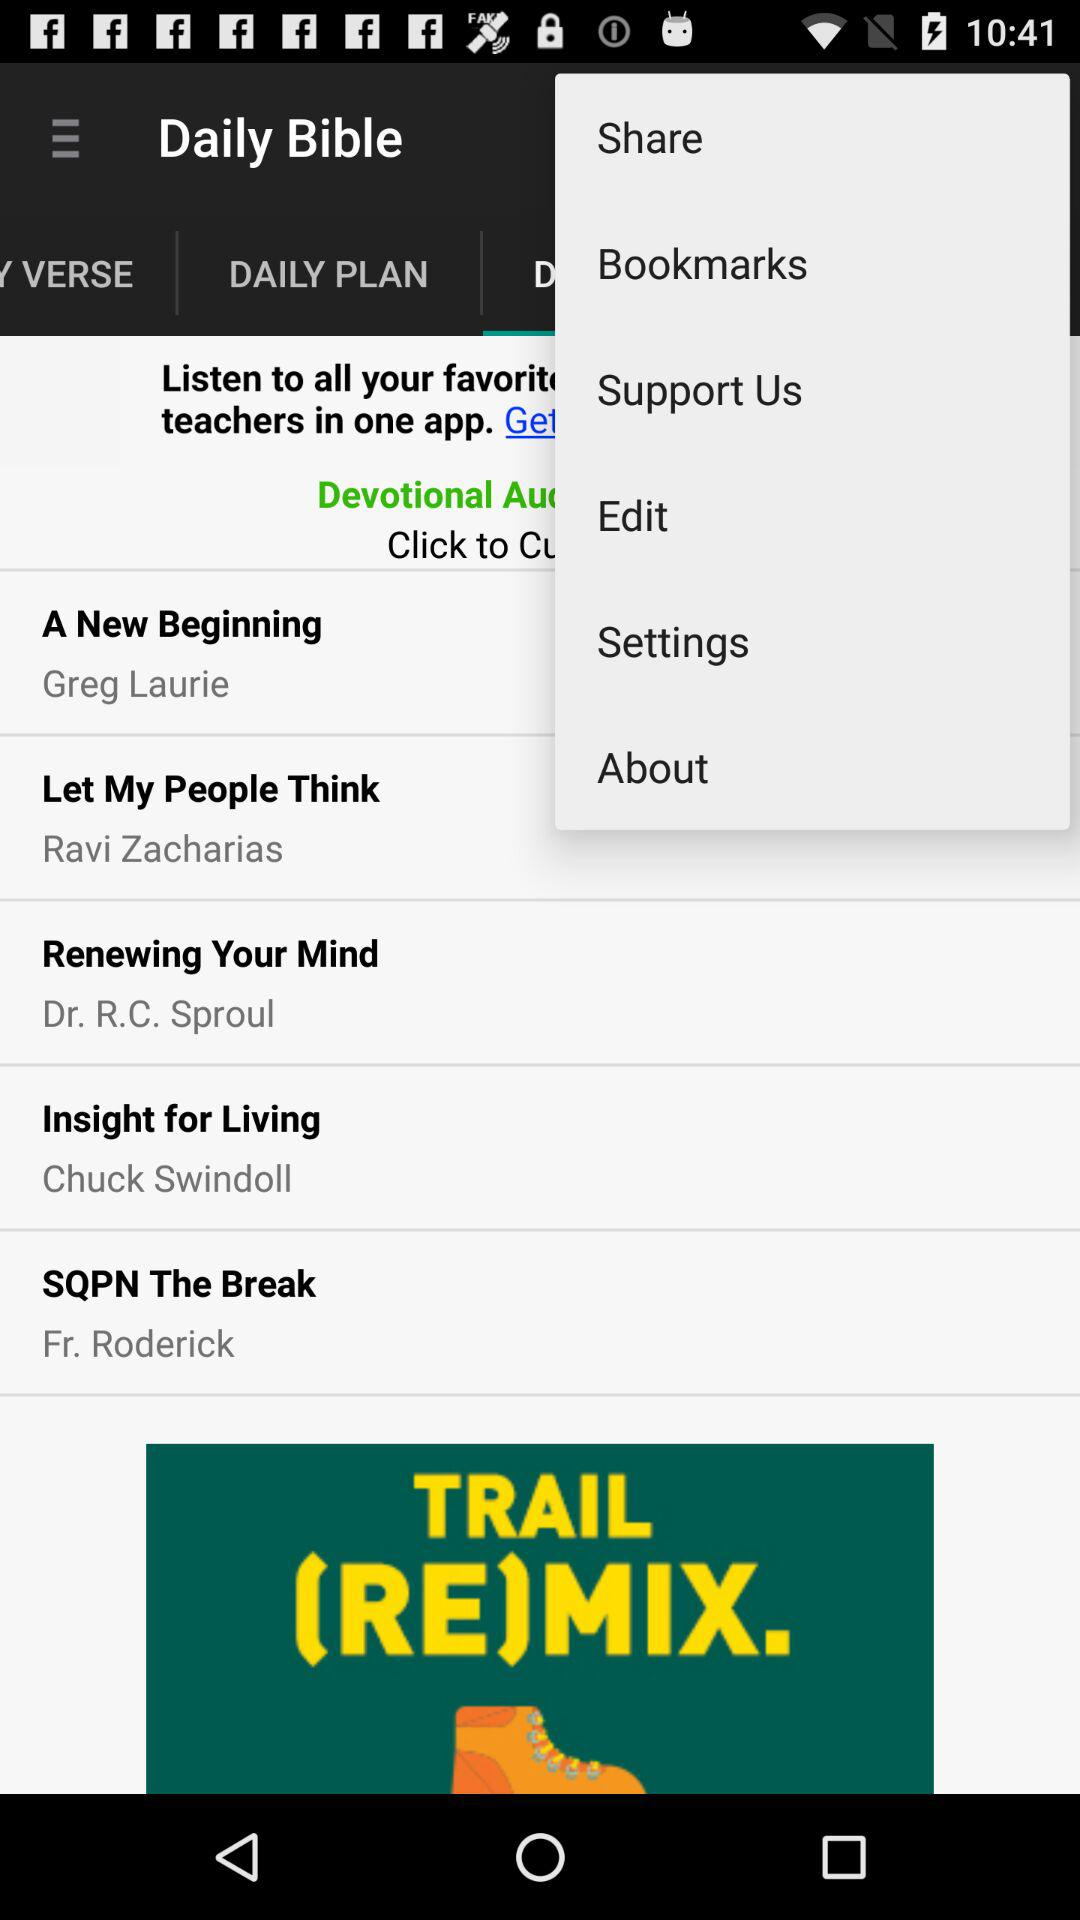What is the application name? The application name is "Daily Bible". 